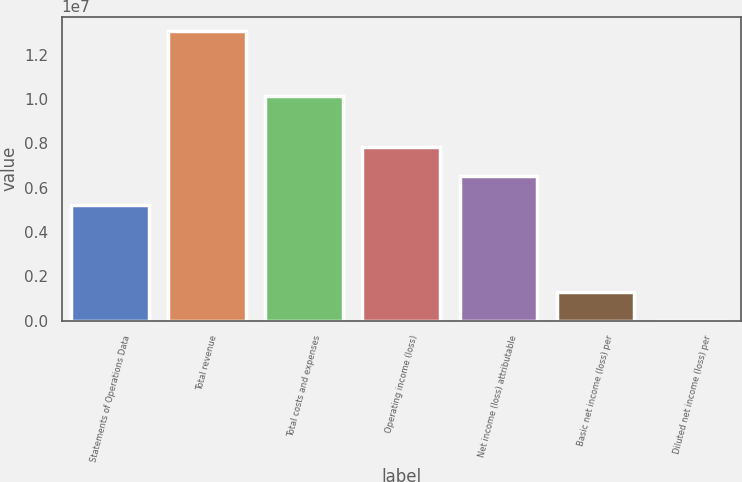Convert chart. <chart><loc_0><loc_0><loc_500><loc_500><bar_chart><fcel>Statements of Operations Data<fcel>Total revenue<fcel>Total costs and expenses<fcel>Operating income (loss)<fcel>Net income (loss) attributable<fcel>Basic net income (loss) per<fcel>Diluted net income (loss) per<nl><fcel>5.22963e+06<fcel>1.30741e+07<fcel>1.01451e+07<fcel>7.84444e+06<fcel>6.53703e+06<fcel>1.30741e+06<fcel>3.39<nl></chart> 